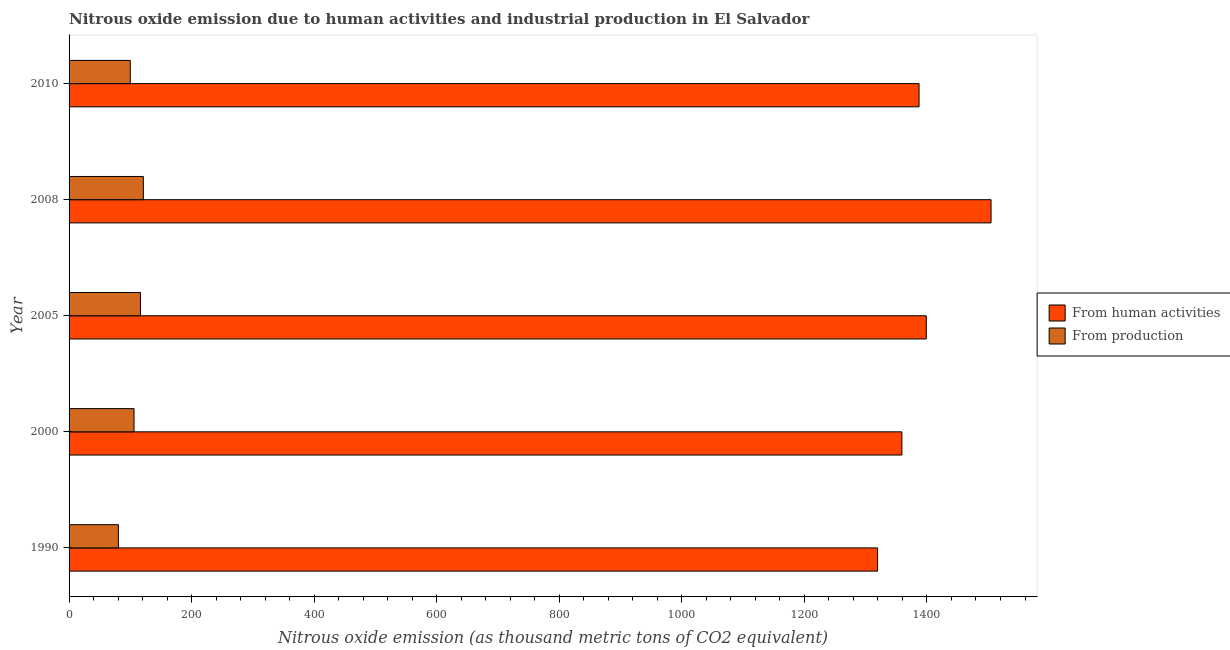How many different coloured bars are there?
Ensure brevity in your answer.  2. Are the number of bars on each tick of the Y-axis equal?
Offer a very short reply. Yes. How many bars are there on the 4th tick from the top?
Offer a very short reply. 2. How many bars are there on the 2nd tick from the bottom?
Make the answer very short. 2. In how many cases, is the number of bars for a given year not equal to the number of legend labels?
Offer a very short reply. 0. What is the amount of emissions generated from industries in 1990?
Your answer should be very brief. 80.5. Across all years, what is the maximum amount of emissions generated from industries?
Ensure brevity in your answer.  121.2. Across all years, what is the minimum amount of emissions from human activities?
Keep it short and to the point. 1319.4. In which year was the amount of emissions generated from industries minimum?
Make the answer very short. 1990. What is the total amount of emissions from human activities in the graph?
Ensure brevity in your answer.  6969.1. What is the difference between the amount of emissions generated from industries in 1990 and that in 2008?
Give a very brief answer. -40.7. What is the difference between the amount of emissions from human activities in 2000 and the amount of emissions generated from industries in 2005?
Make the answer very short. 1242.6. What is the average amount of emissions from human activities per year?
Offer a very short reply. 1393.82. In the year 1990, what is the difference between the amount of emissions from human activities and amount of emissions generated from industries?
Offer a very short reply. 1238.9. In how many years, is the amount of emissions from human activities greater than 440 thousand metric tons?
Provide a short and direct response. 5. What is the ratio of the amount of emissions generated from industries in 1990 to that in 2005?
Your answer should be very brief. 0.69. Is the amount of emissions from human activities in 2000 less than that in 2008?
Your answer should be compact. Yes. What is the difference between the highest and the lowest amount of emissions from human activities?
Make the answer very short. 185.2. In how many years, is the amount of emissions generated from industries greater than the average amount of emissions generated from industries taken over all years?
Your response must be concise. 3. Is the sum of the amount of emissions generated from industries in 2000 and 2010 greater than the maximum amount of emissions from human activities across all years?
Your answer should be compact. No. What does the 2nd bar from the top in 1990 represents?
Your response must be concise. From human activities. What does the 1st bar from the bottom in 2010 represents?
Ensure brevity in your answer.  From human activities. How many bars are there?
Ensure brevity in your answer.  10. Does the graph contain grids?
Ensure brevity in your answer.  No. Where does the legend appear in the graph?
Your response must be concise. Center right. What is the title of the graph?
Provide a succinct answer. Nitrous oxide emission due to human activities and industrial production in El Salvador. Does "Export" appear as one of the legend labels in the graph?
Your answer should be compact. No. What is the label or title of the X-axis?
Your response must be concise. Nitrous oxide emission (as thousand metric tons of CO2 equivalent). What is the label or title of the Y-axis?
Your response must be concise. Year. What is the Nitrous oxide emission (as thousand metric tons of CO2 equivalent) in From human activities in 1990?
Provide a succinct answer. 1319.4. What is the Nitrous oxide emission (as thousand metric tons of CO2 equivalent) in From production in 1990?
Provide a succinct answer. 80.5. What is the Nitrous oxide emission (as thousand metric tons of CO2 equivalent) of From human activities in 2000?
Your answer should be compact. 1359.1. What is the Nitrous oxide emission (as thousand metric tons of CO2 equivalent) in From production in 2000?
Ensure brevity in your answer.  106. What is the Nitrous oxide emission (as thousand metric tons of CO2 equivalent) in From human activities in 2005?
Make the answer very short. 1398.9. What is the Nitrous oxide emission (as thousand metric tons of CO2 equivalent) in From production in 2005?
Provide a succinct answer. 116.5. What is the Nitrous oxide emission (as thousand metric tons of CO2 equivalent) of From human activities in 2008?
Keep it short and to the point. 1504.6. What is the Nitrous oxide emission (as thousand metric tons of CO2 equivalent) in From production in 2008?
Offer a terse response. 121.2. What is the Nitrous oxide emission (as thousand metric tons of CO2 equivalent) in From human activities in 2010?
Make the answer very short. 1387.1. What is the Nitrous oxide emission (as thousand metric tons of CO2 equivalent) of From production in 2010?
Ensure brevity in your answer.  99.9. Across all years, what is the maximum Nitrous oxide emission (as thousand metric tons of CO2 equivalent) in From human activities?
Offer a very short reply. 1504.6. Across all years, what is the maximum Nitrous oxide emission (as thousand metric tons of CO2 equivalent) of From production?
Offer a terse response. 121.2. Across all years, what is the minimum Nitrous oxide emission (as thousand metric tons of CO2 equivalent) of From human activities?
Your response must be concise. 1319.4. Across all years, what is the minimum Nitrous oxide emission (as thousand metric tons of CO2 equivalent) of From production?
Make the answer very short. 80.5. What is the total Nitrous oxide emission (as thousand metric tons of CO2 equivalent) of From human activities in the graph?
Your response must be concise. 6969.1. What is the total Nitrous oxide emission (as thousand metric tons of CO2 equivalent) of From production in the graph?
Ensure brevity in your answer.  524.1. What is the difference between the Nitrous oxide emission (as thousand metric tons of CO2 equivalent) in From human activities in 1990 and that in 2000?
Your answer should be compact. -39.7. What is the difference between the Nitrous oxide emission (as thousand metric tons of CO2 equivalent) of From production in 1990 and that in 2000?
Make the answer very short. -25.5. What is the difference between the Nitrous oxide emission (as thousand metric tons of CO2 equivalent) in From human activities in 1990 and that in 2005?
Your answer should be very brief. -79.5. What is the difference between the Nitrous oxide emission (as thousand metric tons of CO2 equivalent) of From production in 1990 and that in 2005?
Give a very brief answer. -36. What is the difference between the Nitrous oxide emission (as thousand metric tons of CO2 equivalent) of From human activities in 1990 and that in 2008?
Your answer should be very brief. -185.2. What is the difference between the Nitrous oxide emission (as thousand metric tons of CO2 equivalent) in From production in 1990 and that in 2008?
Provide a succinct answer. -40.7. What is the difference between the Nitrous oxide emission (as thousand metric tons of CO2 equivalent) in From human activities in 1990 and that in 2010?
Your answer should be very brief. -67.7. What is the difference between the Nitrous oxide emission (as thousand metric tons of CO2 equivalent) of From production in 1990 and that in 2010?
Give a very brief answer. -19.4. What is the difference between the Nitrous oxide emission (as thousand metric tons of CO2 equivalent) of From human activities in 2000 and that in 2005?
Make the answer very short. -39.8. What is the difference between the Nitrous oxide emission (as thousand metric tons of CO2 equivalent) of From production in 2000 and that in 2005?
Your answer should be compact. -10.5. What is the difference between the Nitrous oxide emission (as thousand metric tons of CO2 equivalent) of From human activities in 2000 and that in 2008?
Your response must be concise. -145.5. What is the difference between the Nitrous oxide emission (as thousand metric tons of CO2 equivalent) of From production in 2000 and that in 2008?
Ensure brevity in your answer.  -15.2. What is the difference between the Nitrous oxide emission (as thousand metric tons of CO2 equivalent) of From human activities in 2000 and that in 2010?
Make the answer very short. -28. What is the difference between the Nitrous oxide emission (as thousand metric tons of CO2 equivalent) in From human activities in 2005 and that in 2008?
Provide a succinct answer. -105.7. What is the difference between the Nitrous oxide emission (as thousand metric tons of CO2 equivalent) in From human activities in 2005 and that in 2010?
Your answer should be compact. 11.8. What is the difference between the Nitrous oxide emission (as thousand metric tons of CO2 equivalent) of From production in 2005 and that in 2010?
Offer a terse response. 16.6. What is the difference between the Nitrous oxide emission (as thousand metric tons of CO2 equivalent) of From human activities in 2008 and that in 2010?
Offer a very short reply. 117.5. What is the difference between the Nitrous oxide emission (as thousand metric tons of CO2 equivalent) of From production in 2008 and that in 2010?
Offer a terse response. 21.3. What is the difference between the Nitrous oxide emission (as thousand metric tons of CO2 equivalent) of From human activities in 1990 and the Nitrous oxide emission (as thousand metric tons of CO2 equivalent) of From production in 2000?
Your response must be concise. 1213.4. What is the difference between the Nitrous oxide emission (as thousand metric tons of CO2 equivalent) in From human activities in 1990 and the Nitrous oxide emission (as thousand metric tons of CO2 equivalent) in From production in 2005?
Your response must be concise. 1202.9. What is the difference between the Nitrous oxide emission (as thousand metric tons of CO2 equivalent) in From human activities in 1990 and the Nitrous oxide emission (as thousand metric tons of CO2 equivalent) in From production in 2008?
Offer a terse response. 1198.2. What is the difference between the Nitrous oxide emission (as thousand metric tons of CO2 equivalent) of From human activities in 1990 and the Nitrous oxide emission (as thousand metric tons of CO2 equivalent) of From production in 2010?
Keep it short and to the point. 1219.5. What is the difference between the Nitrous oxide emission (as thousand metric tons of CO2 equivalent) of From human activities in 2000 and the Nitrous oxide emission (as thousand metric tons of CO2 equivalent) of From production in 2005?
Your answer should be very brief. 1242.6. What is the difference between the Nitrous oxide emission (as thousand metric tons of CO2 equivalent) of From human activities in 2000 and the Nitrous oxide emission (as thousand metric tons of CO2 equivalent) of From production in 2008?
Keep it short and to the point. 1237.9. What is the difference between the Nitrous oxide emission (as thousand metric tons of CO2 equivalent) in From human activities in 2000 and the Nitrous oxide emission (as thousand metric tons of CO2 equivalent) in From production in 2010?
Your response must be concise. 1259.2. What is the difference between the Nitrous oxide emission (as thousand metric tons of CO2 equivalent) of From human activities in 2005 and the Nitrous oxide emission (as thousand metric tons of CO2 equivalent) of From production in 2008?
Ensure brevity in your answer.  1277.7. What is the difference between the Nitrous oxide emission (as thousand metric tons of CO2 equivalent) in From human activities in 2005 and the Nitrous oxide emission (as thousand metric tons of CO2 equivalent) in From production in 2010?
Ensure brevity in your answer.  1299. What is the difference between the Nitrous oxide emission (as thousand metric tons of CO2 equivalent) of From human activities in 2008 and the Nitrous oxide emission (as thousand metric tons of CO2 equivalent) of From production in 2010?
Your answer should be very brief. 1404.7. What is the average Nitrous oxide emission (as thousand metric tons of CO2 equivalent) in From human activities per year?
Your answer should be compact. 1393.82. What is the average Nitrous oxide emission (as thousand metric tons of CO2 equivalent) in From production per year?
Give a very brief answer. 104.82. In the year 1990, what is the difference between the Nitrous oxide emission (as thousand metric tons of CO2 equivalent) of From human activities and Nitrous oxide emission (as thousand metric tons of CO2 equivalent) of From production?
Provide a short and direct response. 1238.9. In the year 2000, what is the difference between the Nitrous oxide emission (as thousand metric tons of CO2 equivalent) of From human activities and Nitrous oxide emission (as thousand metric tons of CO2 equivalent) of From production?
Make the answer very short. 1253.1. In the year 2005, what is the difference between the Nitrous oxide emission (as thousand metric tons of CO2 equivalent) in From human activities and Nitrous oxide emission (as thousand metric tons of CO2 equivalent) in From production?
Your answer should be compact. 1282.4. In the year 2008, what is the difference between the Nitrous oxide emission (as thousand metric tons of CO2 equivalent) in From human activities and Nitrous oxide emission (as thousand metric tons of CO2 equivalent) in From production?
Make the answer very short. 1383.4. In the year 2010, what is the difference between the Nitrous oxide emission (as thousand metric tons of CO2 equivalent) in From human activities and Nitrous oxide emission (as thousand metric tons of CO2 equivalent) in From production?
Offer a very short reply. 1287.2. What is the ratio of the Nitrous oxide emission (as thousand metric tons of CO2 equivalent) of From human activities in 1990 to that in 2000?
Give a very brief answer. 0.97. What is the ratio of the Nitrous oxide emission (as thousand metric tons of CO2 equivalent) in From production in 1990 to that in 2000?
Provide a succinct answer. 0.76. What is the ratio of the Nitrous oxide emission (as thousand metric tons of CO2 equivalent) of From human activities in 1990 to that in 2005?
Offer a terse response. 0.94. What is the ratio of the Nitrous oxide emission (as thousand metric tons of CO2 equivalent) in From production in 1990 to that in 2005?
Ensure brevity in your answer.  0.69. What is the ratio of the Nitrous oxide emission (as thousand metric tons of CO2 equivalent) of From human activities in 1990 to that in 2008?
Your answer should be compact. 0.88. What is the ratio of the Nitrous oxide emission (as thousand metric tons of CO2 equivalent) in From production in 1990 to that in 2008?
Your response must be concise. 0.66. What is the ratio of the Nitrous oxide emission (as thousand metric tons of CO2 equivalent) in From human activities in 1990 to that in 2010?
Your response must be concise. 0.95. What is the ratio of the Nitrous oxide emission (as thousand metric tons of CO2 equivalent) in From production in 1990 to that in 2010?
Your answer should be compact. 0.81. What is the ratio of the Nitrous oxide emission (as thousand metric tons of CO2 equivalent) of From human activities in 2000 to that in 2005?
Give a very brief answer. 0.97. What is the ratio of the Nitrous oxide emission (as thousand metric tons of CO2 equivalent) of From production in 2000 to that in 2005?
Provide a short and direct response. 0.91. What is the ratio of the Nitrous oxide emission (as thousand metric tons of CO2 equivalent) in From human activities in 2000 to that in 2008?
Your response must be concise. 0.9. What is the ratio of the Nitrous oxide emission (as thousand metric tons of CO2 equivalent) in From production in 2000 to that in 2008?
Keep it short and to the point. 0.87. What is the ratio of the Nitrous oxide emission (as thousand metric tons of CO2 equivalent) in From human activities in 2000 to that in 2010?
Keep it short and to the point. 0.98. What is the ratio of the Nitrous oxide emission (as thousand metric tons of CO2 equivalent) in From production in 2000 to that in 2010?
Make the answer very short. 1.06. What is the ratio of the Nitrous oxide emission (as thousand metric tons of CO2 equivalent) in From human activities in 2005 to that in 2008?
Your response must be concise. 0.93. What is the ratio of the Nitrous oxide emission (as thousand metric tons of CO2 equivalent) in From production in 2005 to that in 2008?
Your answer should be very brief. 0.96. What is the ratio of the Nitrous oxide emission (as thousand metric tons of CO2 equivalent) of From human activities in 2005 to that in 2010?
Your response must be concise. 1.01. What is the ratio of the Nitrous oxide emission (as thousand metric tons of CO2 equivalent) in From production in 2005 to that in 2010?
Keep it short and to the point. 1.17. What is the ratio of the Nitrous oxide emission (as thousand metric tons of CO2 equivalent) in From human activities in 2008 to that in 2010?
Provide a short and direct response. 1.08. What is the ratio of the Nitrous oxide emission (as thousand metric tons of CO2 equivalent) of From production in 2008 to that in 2010?
Make the answer very short. 1.21. What is the difference between the highest and the second highest Nitrous oxide emission (as thousand metric tons of CO2 equivalent) of From human activities?
Provide a succinct answer. 105.7. What is the difference between the highest and the second highest Nitrous oxide emission (as thousand metric tons of CO2 equivalent) of From production?
Provide a short and direct response. 4.7. What is the difference between the highest and the lowest Nitrous oxide emission (as thousand metric tons of CO2 equivalent) in From human activities?
Provide a succinct answer. 185.2. What is the difference between the highest and the lowest Nitrous oxide emission (as thousand metric tons of CO2 equivalent) of From production?
Offer a terse response. 40.7. 